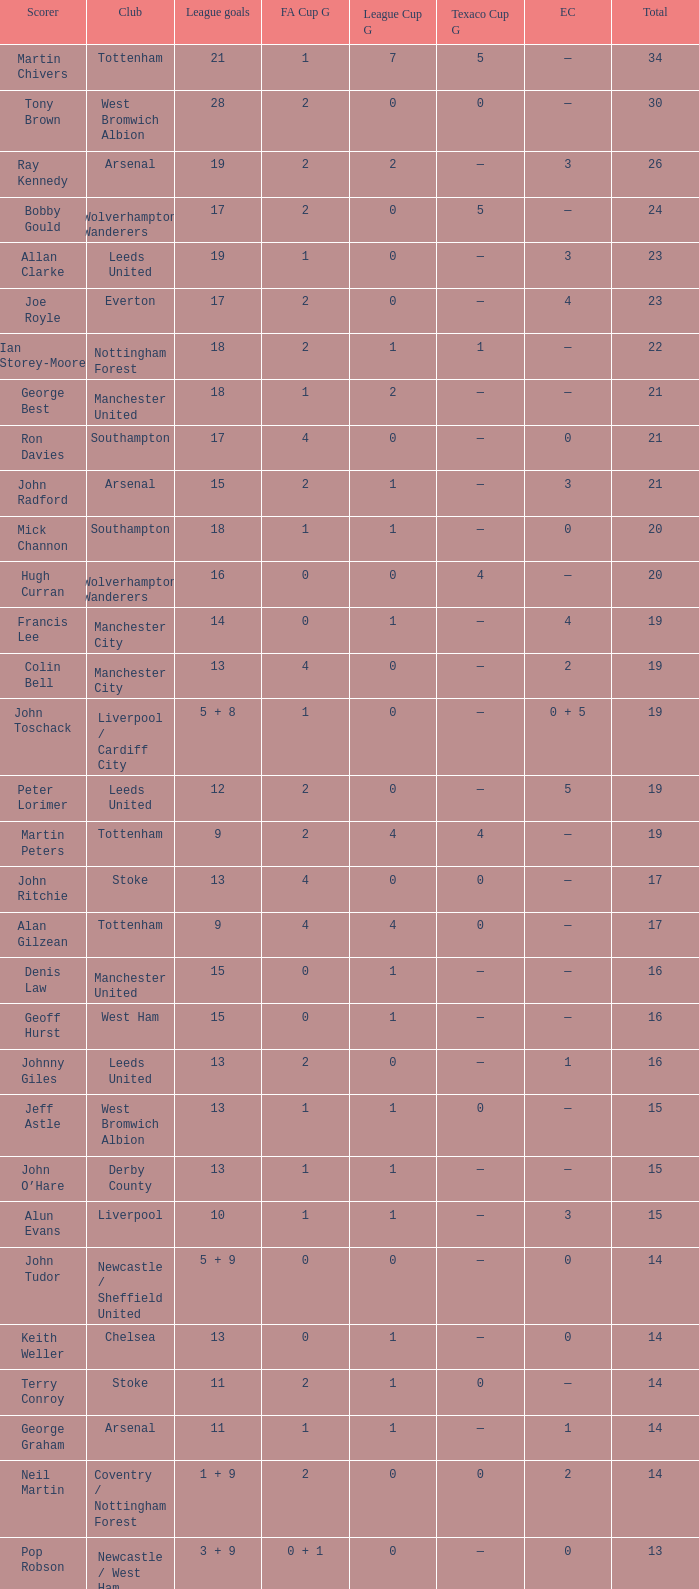I'm looking to parse the entire table for insights. Could you assist me with that? {'header': ['Scorer', 'Club', 'League goals', 'FA Cup G', 'League Cup G', 'Texaco Cup G', 'EC', 'Total'], 'rows': [['Martin Chivers', 'Tottenham', '21', '1', '7', '5', '—', '34'], ['Tony Brown', 'West Bromwich Albion', '28', '2', '0', '0', '—', '30'], ['Ray Kennedy', 'Arsenal', '19', '2', '2', '—', '3', '26'], ['Bobby Gould', 'Wolverhampton Wanderers', '17', '2', '0', '5', '—', '24'], ['Allan Clarke', 'Leeds United', '19', '1', '0', '—', '3', '23'], ['Joe Royle', 'Everton', '17', '2', '0', '—', '4', '23'], ['Ian Storey-Moore', 'Nottingham Forest', '18', '2', '1', '1', '—', '22'], ['George Best', 'Manchester United', '18', '1', '2', '—', '—', '21'], ['Ron Davies', 'Southampton', '17', '4', '0', '—', '0', '21'], ['John Radford', 'Arsenal', '15', '2', '1', '—', '3', '21'], ['Mick Channon', 'Southampton', '18', '1', '1', '—', '0', '20'], ['Hugh Curran', 'Wolverhampton Wanderers', '16', '0', '0', '4', '—', '20'], ['Francis Lee', 'Manchester City', '14', '0', '1', '—', '4', '19'], ['Colin Bell', 'Manchester City', '13', '4', '0', '—', '2', '19'], ['John Toschack', 'Liverpool / Cardiff City', '5 + 8', '1', '0', '—', '0 + 5', '19'], ['Peter Lorimer', 'Leeds United', '12', '2', '0', '—', '5', '19'], ['Martin Peters', 'Tottenham', '9', '2', '4', '4', '—', '19'], ['John Ritchie', 'Stoke', '13', '4', '0', '0', '—', '17'], ['Alan Gilzean', 'Tottenham', '9', '4', '4', '0', '—', '17'], ['Denis Law', 'Manchester United', '15', '0', '1', '—', '—', '16'], ['Geoff Hurst', 'West Ham', '15', '0', '1', '—', '—', '16'], ['Johnny Giles', 'Leeds United', '13', '2', '0', '—', '1', '16'], ['Jeff Astle', 'West Bromwich Albion', '13', '1', '1', '0', '—', '15'], ['John O’Hare', 'Derby County', '13', '1', '1', '—', '—', '15'], ['Alun Evans', 'Liverpool', '10', '1', '1', '—', '3', '15'], ['John Tudor', 'Newcastle / Sheffield United', '5 + 9', '0', '0', '—', '0', '14'], ['Keith Weller', 'Chelsea', '13', '0', '1', '—', '0', '14'], ['Terry Conroy', 'Stoke', '11', '2', '1', '0', '—', '14'], ['George Graham', 'Arsenal', '11', '1', '1', '—', '1', '14'], ['Neil Martin', 'Coventry / Nottingham Forest', '1 + 9', '2', '0', '0', '2', '14'], ['Pop Robson', 'Newcastle / West Ham', '3 + 9', '0 + 1', '0', '—', '0', '13'], ['Derek Dougan', 'Wolverhampton Wanderers', '12', '0', '0', '1', '—', '13'], ['Alan Birchenall', 'Crystal Palace', '10', '1', '2', '—', '—', '13'], ['Ernie Hunt', 'Coventry', '10', '1', '1', '—', '1', '13'], ['Brian Kidd', 'Manchester United', '8', '0', '5', '—', '—', '13'], ['Kevin Hector', 'Derby County', '11', '0', '1', '—', '—', '12'], ['/ Colin Viljoen', 'Ipswich Town', '10', '2', '0', '—', '—', '12'], ['Alan Hinton', 'Derby County', '10', '1', '1', '—', '—', '12'], ['Gerry Queen', 'Crystal Palace', '9', '0', '3', '—', '—', '12'], ['Peter Cormack', 'Nottingham Forest', '8', '1', '1', '2', '—', '12'], ['Frank Worthington', 'Huddersfield', '9', '2', '0', '—', '—', '11'], ['Mickey Burns', 'Blackpool', '10', '0', '0', '—', '—', '10'], ['Frank James Clarke', 'Ipswich Town', '8', '2', '0', '—', '—', '10'], ['Jimmy Greenhoff', 'Stoke', '7', '3', '0', '0', '—', '10'], ['Charlie George', 'Arsenal', '5', '5', '0', '—', '0', '10']]} What is the average Total, when FA Cup Goals is 1, when League Goals is 10, and when Club is Crystal Palace? 13.0. 